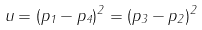Convert formula to latex. <formula><loc_0><loc_0><loc_500><loc_500>u = ( p _ { 1 } - p _ { 4 } ) ^ { 2 } = ( p _ { 3 } - p _ { 2 } ) ^ { 2 }</formula> 